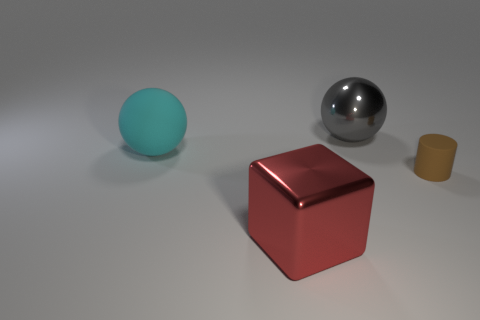Do the big gray metal object and the big matte object have the same shape?
Give a very brief answer. Yes. Does the metal thing that is behind the big shiny cube have the same size as the rubber thing on the right side of the big metal cube?
Your answer should be very brief. No. There is a cyan object that is the same shape as the gray object; what is its size?
Ensure brevity in your answer.  Large. Is the number of gray balls behind the big shiny block greater than the number of large matte objects that are behind the cyan ball?
Your answer should be compact. Yes. The object that is in front of the gray ball and on the right side of the metallic cube is made of what material?
Provide a succinct answer. Rubber. The other thing that is the same shape as the large gray metal object is what color?
Provide a succinct answer. Cyan. The gray ball has what size?
Your answer should be very brief. Large. There is a metallic thing on the left side of the large metallic object that is behind the tiny brown rubber object; what is its color?
Offer a very short reply. Red. What number of things are to the right of the cyan matte object and behind the rubber cylinder?
Your response must be concise. 1. Are there more tiny cylinders than big gray matte cylinders?
Your response must be concise. Yes. 